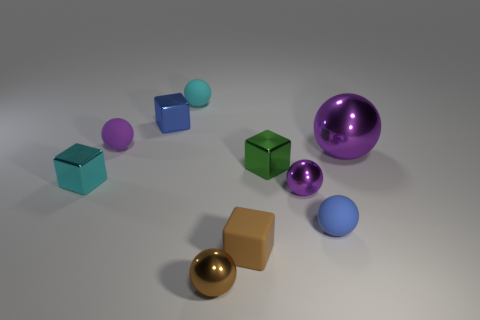Do the purple metallic object that is in front of the large purple ball and the tiny cyan thing that is left of the tiny purple rubber thing have the same shape?
Make the answer very short. No. Is the material of the tiny brown sphere the same as the cyan sphere?
Ensure brevity in your answer.  No. How big is the blue ball that is in front of the purple thing on the right side of the tiny purple thing that is in front of the purple matte thing?
Make the answer very short. Small. How many other things are the same color as the tiny rubber block?
Offer a terse response. 1. There is a blue rubber thing that is the same size as the cyan ball; what shape is it?
Make the answer very short. Sphere. What number of large things are brown things or green metallic blocks?
Your response must be concise. 0. There is a small cyan object that is left of the ball that is on the left side of the small blue block; are there any tiny metallic cubes in front of it?
Give a very brief answer. No. Are there any blue metallic blocks of the same size as the purple rubber object?
Give a very brief answer. Yes. What material is the cyan thing that is the same size as the cyan metallic block?
Ensure brevity in your answer.  Rubber. Does the brown metallic ball have the same size as the matte sphere right of the cyan rubber ball?
Your response must be concise. Yes. 